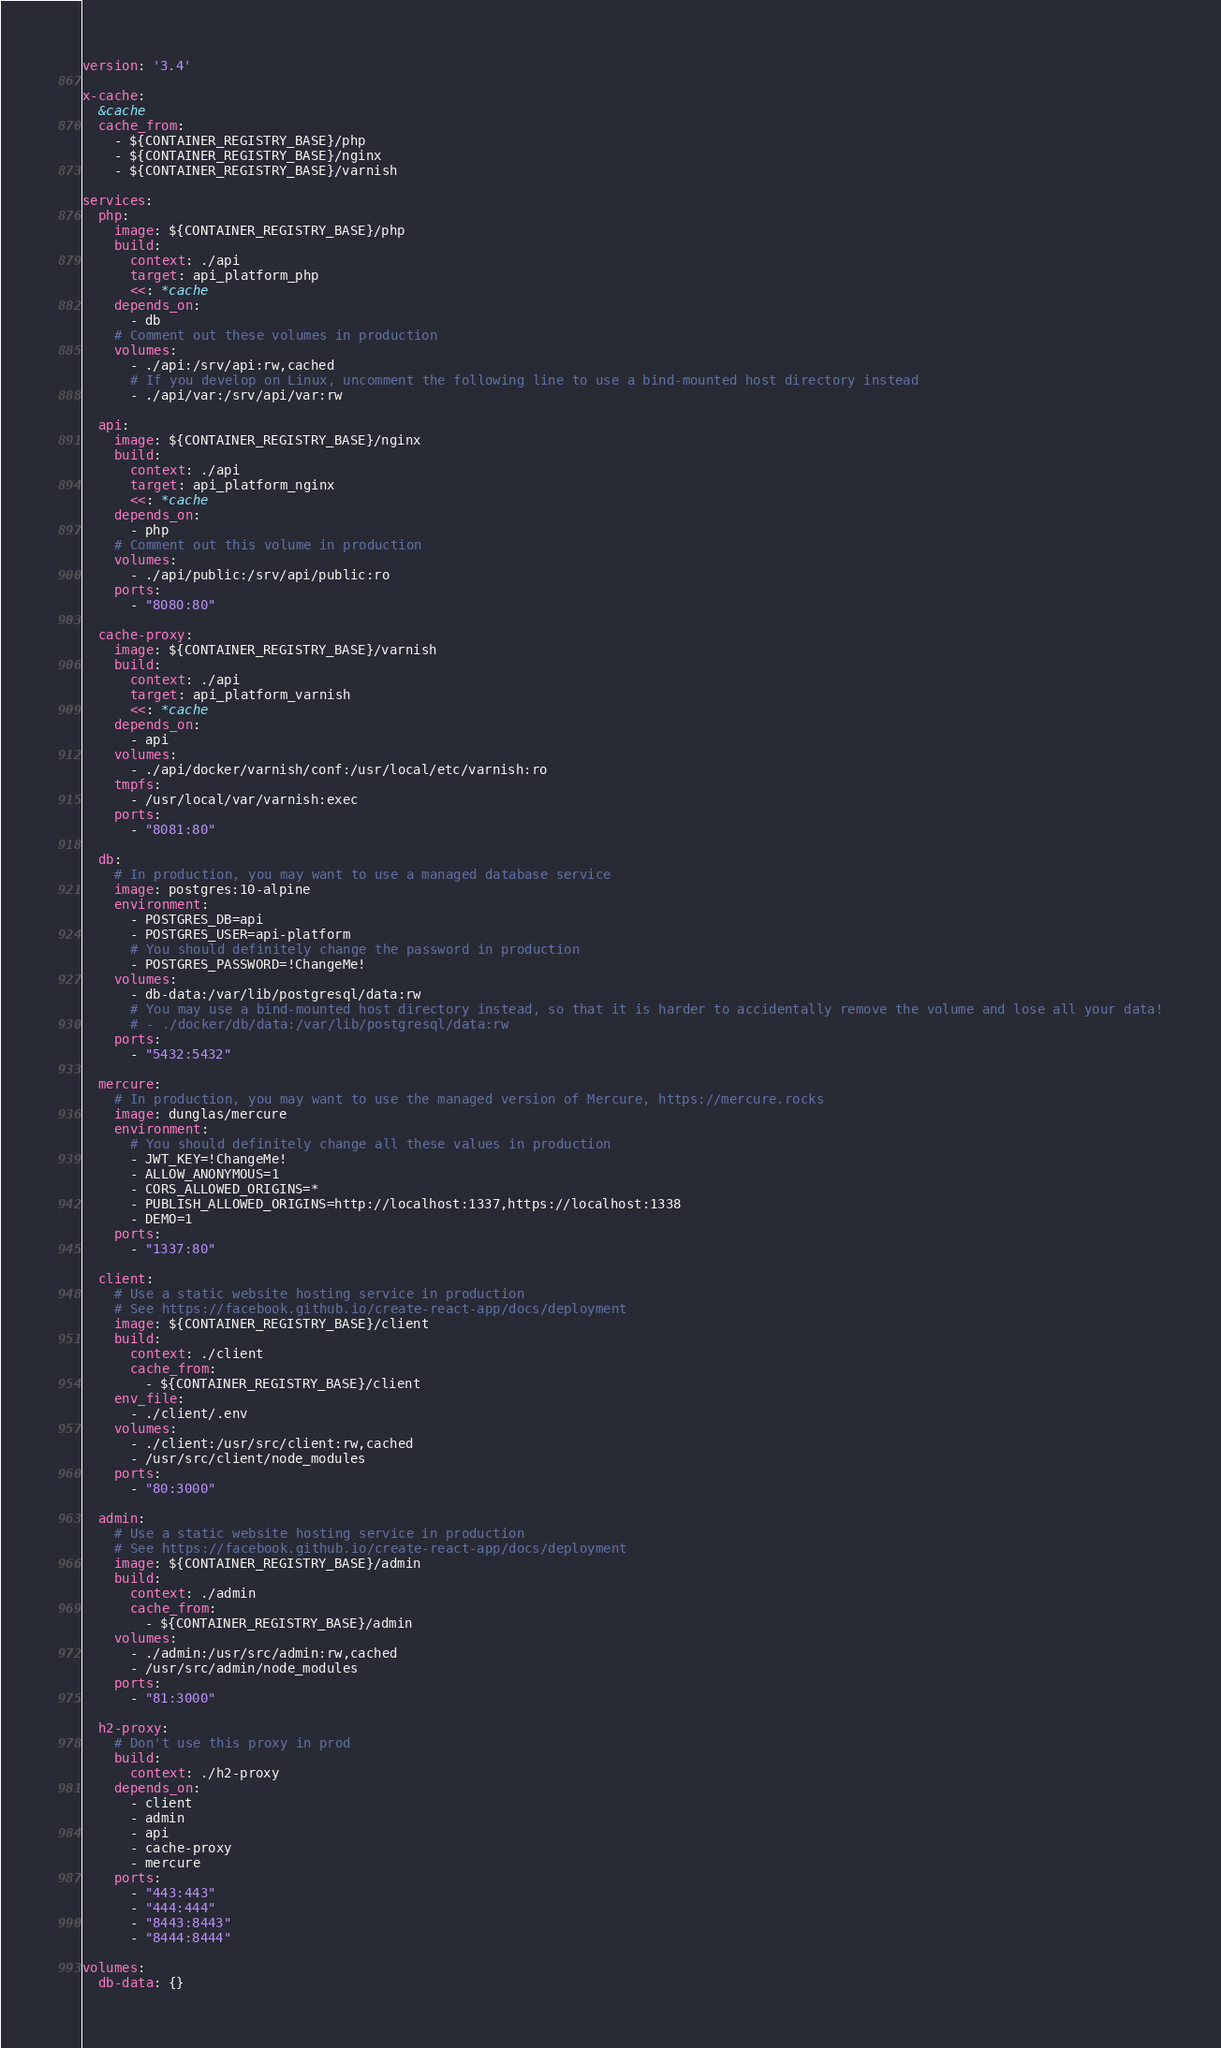<code> <loc_0><loc_0><loc_500><loc_500><_YAML_>version: '3.4'

x-cache:
  &cache
  cache_from:
    - ${CONTAINER_REGISTRY_BASE}/php
    - ${CONTAINER_REGISTRY_BASE}/nginx
    - ${CONTAINER_REGISTRY_BASE}/varnish

services:
  php:
    image: ${CONTAINER_REGISTRY_BASE}/php
    build:
      context: ./api
      target: api_platform_php
      <<: *cache
    depends_on:
      - db
    # Comment out these volumes in production
    volumes:
      - ./api:/srv/api:rw,cached
      # If you develop on Linux, uncomment the following line to use a bind-mounted host directory instead
      - ./api/var:/srv/api/var:rw

  api:
    image: ${CONTAINER_REGISTRY_BASE}/nginx
    build:
      context: ./api
      target: api_platform_nginx
      <<: *cache
    depends_on:
      - php
    # Comment out this volume in production
    volumes:
      - ./api/public:/srv/api/public:ro
    ports:
      - "8080:80"

  cache-proxy:
    image: ${CONTAINER_REGISTRY_BASE}/varnish
    build:
      context: ./api
      target: api_platform_varnish
      <<: *cache
    depends_on:
      - api
    volumes:
      - ./api/docker/varnish/conf:/usr/local/etc/varnish:ro
    tmpfs:
      - /usr/local/var/varnish:exec
    ports:
      - "8081:80"

  db:
    # In production, you may want to use a managed database service
    image: postgres:10-alpine
    environment:
      - POSTGRES_DB=api
      - POSTGRES_USER=api-platform
      # You should definitely change the password in production
      - POSTGRES_PASSWORD=!ChangeMe!
    volumes:
      - db-data:/var/lib/postgresql/data:rw
      # You may use a bind-mounted host directory instead, so that it is harder to accidentally remove the volume and lose all your data!
      # - ./docker/db/data:/var/lib/postgresql/data:rw
    ports:
      - "5432:5432"

  mercure:
    # In production, you may want to use the managed version of Mercure, https://mercure.rocks
    image: dunglas/mercure
    environment:
      # You should definitely change all these values in production
      - JWT_KEY=!ChangeMe!
      - ALLOW_ANONYMOUS=1
      - CORS_ALLOWED_ORIGINS=*
      - PUBLISH_ALLOWED_ORIGINS=http://localhost:1337,https://localhost:1338
      - DEMO=1
    ports:
      - "1337:80"

  client:
    # Use a static website hosting service in production
    # See https://facebook.github.io/create-react-app/docs/deployment
    image: ${CONTAINER_REGISTRY_BASE}/client
    build:
      context: ./client
      cache_from:
        - ${CONTAINER_REGISTRY_BASE}/client
    env_file:
      - ./client/.env
    volumes:
      - ./client:/usr/src/client:rw,cached
      - /usr/src/client/node_modules
    ports:
      - "80:3000"

  admin:
    # Use a static website hosting service in production
    # See https://facebook.github.io/create-react-app/docs/deployment
    image: ${CONTAINER_REGISTRY_BASE}/admin
    build:
      context: ./admin
      cache_from:
        - ${CONTAINER_REGISTRY_BASE}/admin
    volumes:
      - ./admin:/usr/src/admin:rw,cached
      - /usr/src/admin/node_modules
    ports:
      - "81:3000"

  h2-proxy:
    # Don't use this proxy in prod
    build:
      context: ./h2-proxy
    depends_on:
      - client
      - admin
      - api
      - cache-proxy
      - mercure
    ports:
      - "443:443"
      - "444:444"
      - "8443:8443"
      - "8444:8444"

volumes:
  db-data: {}
</code> 